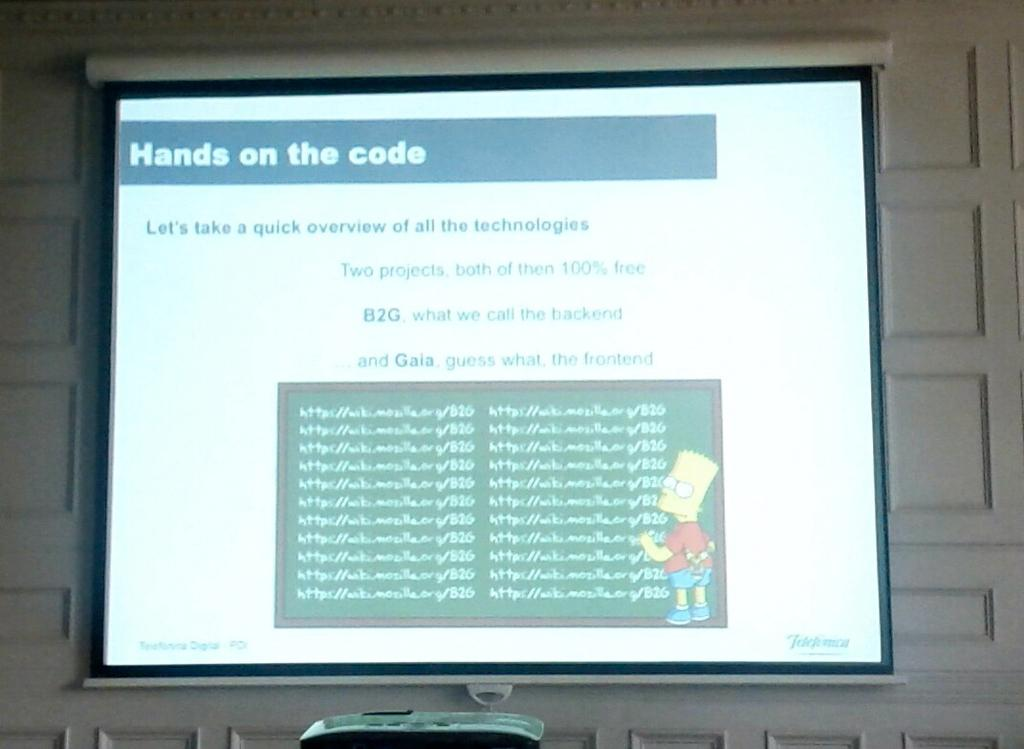<image>
Render a clear and concise summary of the photo. A projector screen shows a lesson on coding titled Hands on the Code. 